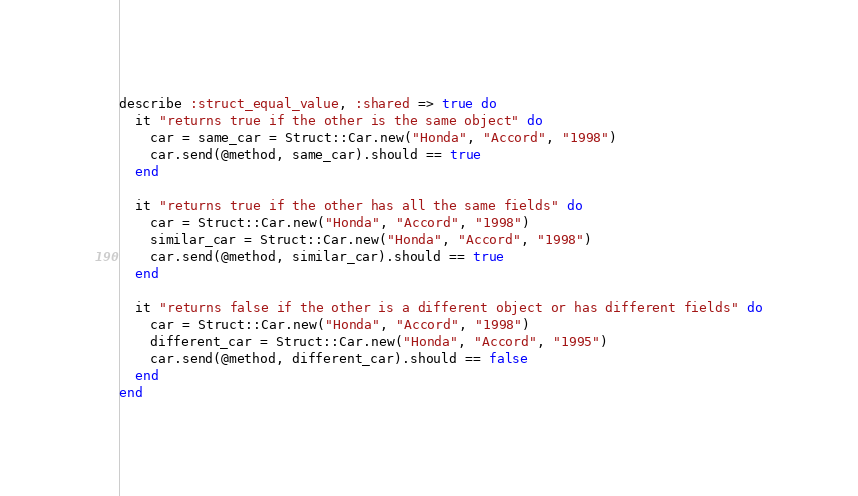Convert code to text. <code><loc_0><loc_0><loc_500><loc_500><_Ruby_>describe :struct_equal_value, :shared => true do
  it "returns true if the other is the same object" do
    car = same_car = Struct::Car.new("Honda", "Accord", "1998")
    car.send(@method, same_car).should == true
  end

  it "returns true if the other has all the same fields" do
    car = Struct::Car.new("Honda", "Accord", "1998")
    similar_car = Struct::Car.new("Honda", "Accord", "1998")
    car.send(@method, similar_car).should == true
  end

  it "returns false if the other is a different object or has different fields" do
    car = Struct::Car.new("Honda", "Accord", "1998")
    different_car = Struct::Car.new("Honda", "Accord", "1995")
    car.send(@method, different_car).should == false
  end
end
</code> 